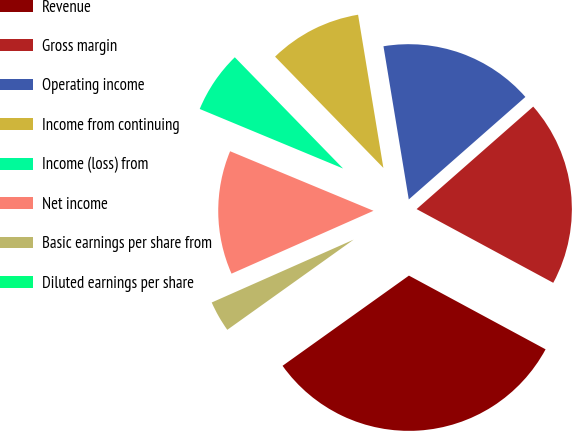Convert chart to OTSL. <chart><loc_0><loc_0><loc_500><loc_500><pie_chart><fcel>Revenue<fcel>Gross margin<fcel>Operating income<fcel>Income from continuing<fcel>Income (loss) from<fcel>Net income<fcel>Basic earnings per share from<fcel>Diluted earnings per share<nl><fcel>32.26%<fcel>19.35%<fcel>16.13%<fcel>9.68%<fcel>6.45%<fcel>12.9%<fcel>3.23%<fcel>0.0%<nl></chart> 